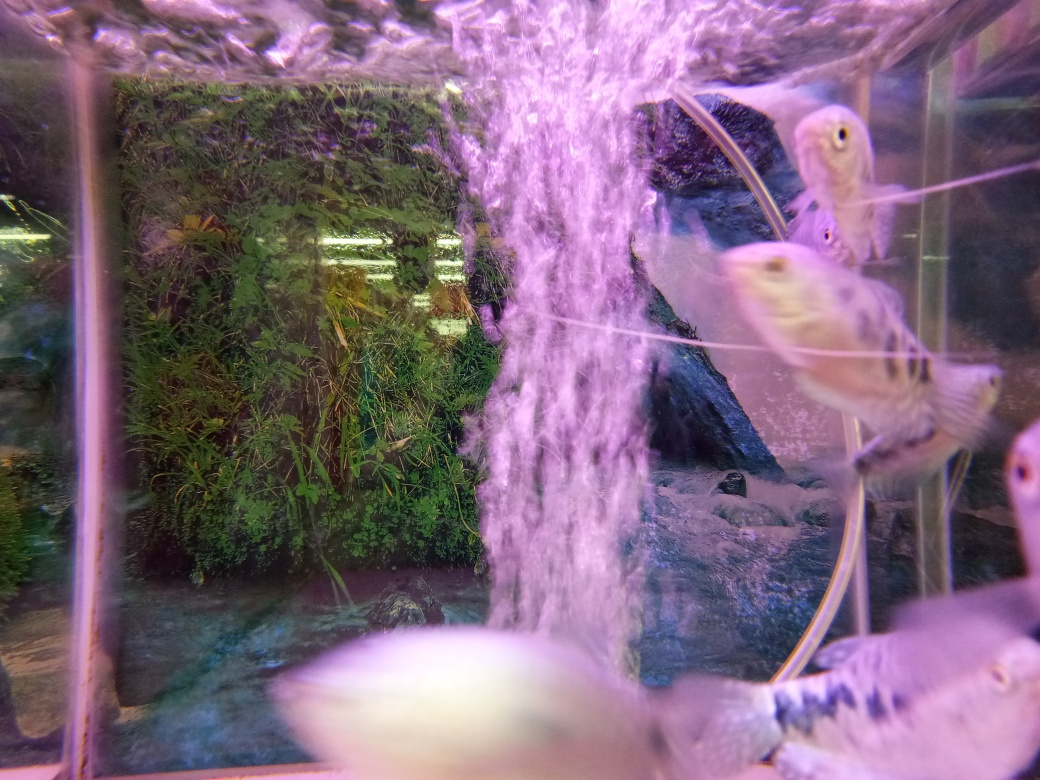What do you think is the mood or atmosphere conveyed by this image? The image conveys a serene and tranquil atmosphere, reminiscent of a quiet underwater scene. The gentle movement of the fish, the soft flow of bubbles, and the lush greenery all contribute to a sense of calmness and relaxation. The diffused lighting gives a dreamy quality to the photo, further enhancing the peaceful ambiance. 